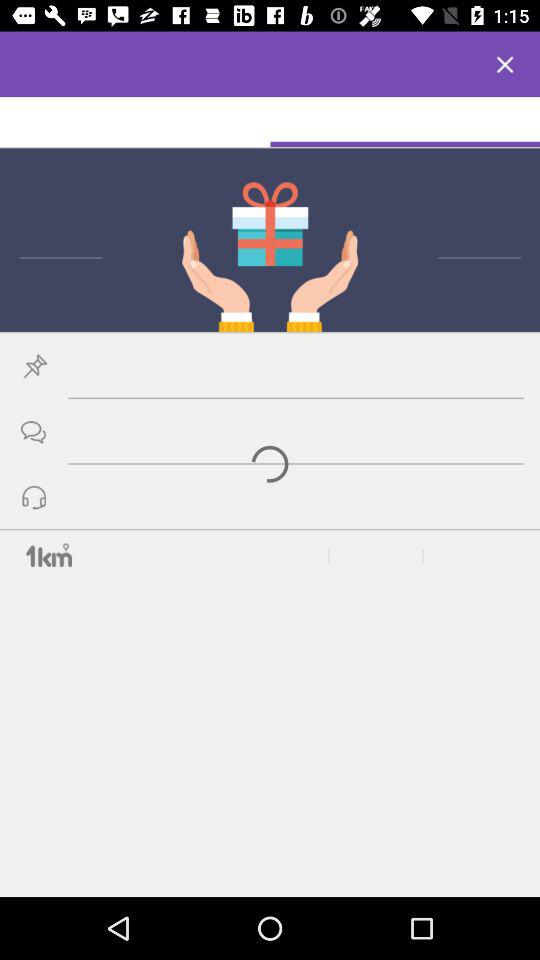How many text input fields are there on the screen?
Answer the question using a single word or phrase. 3 